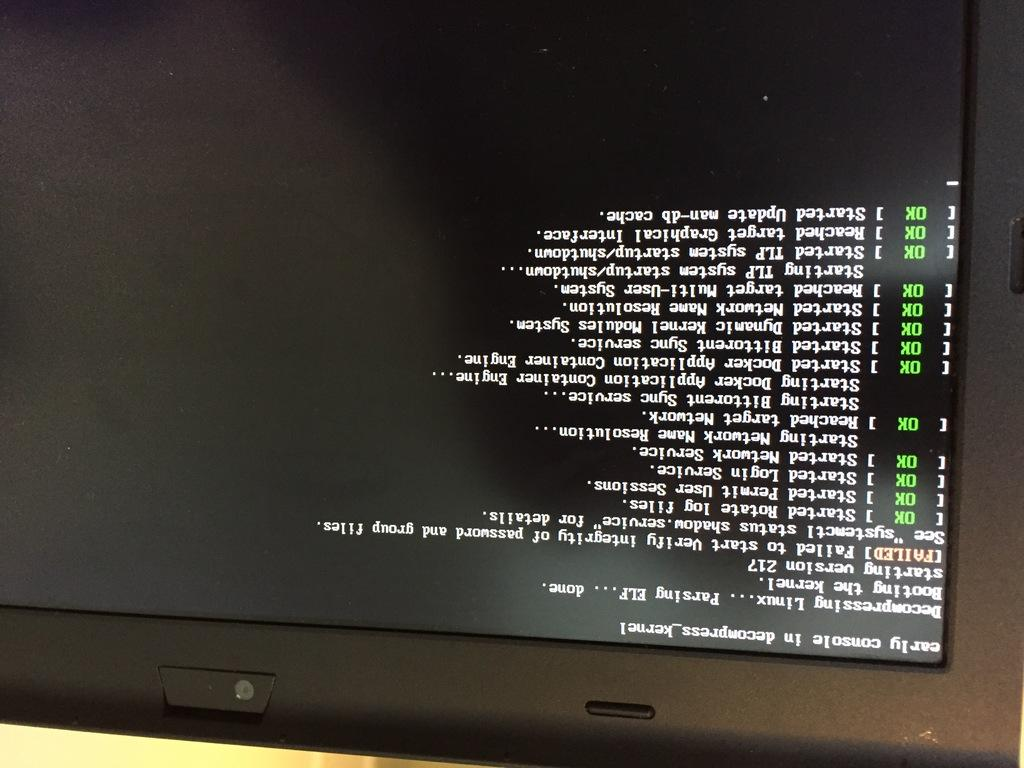<image>
Write a terse but informative summary of the picture. An upside down image of a computer screen which shows many successful commands and one failed command. 